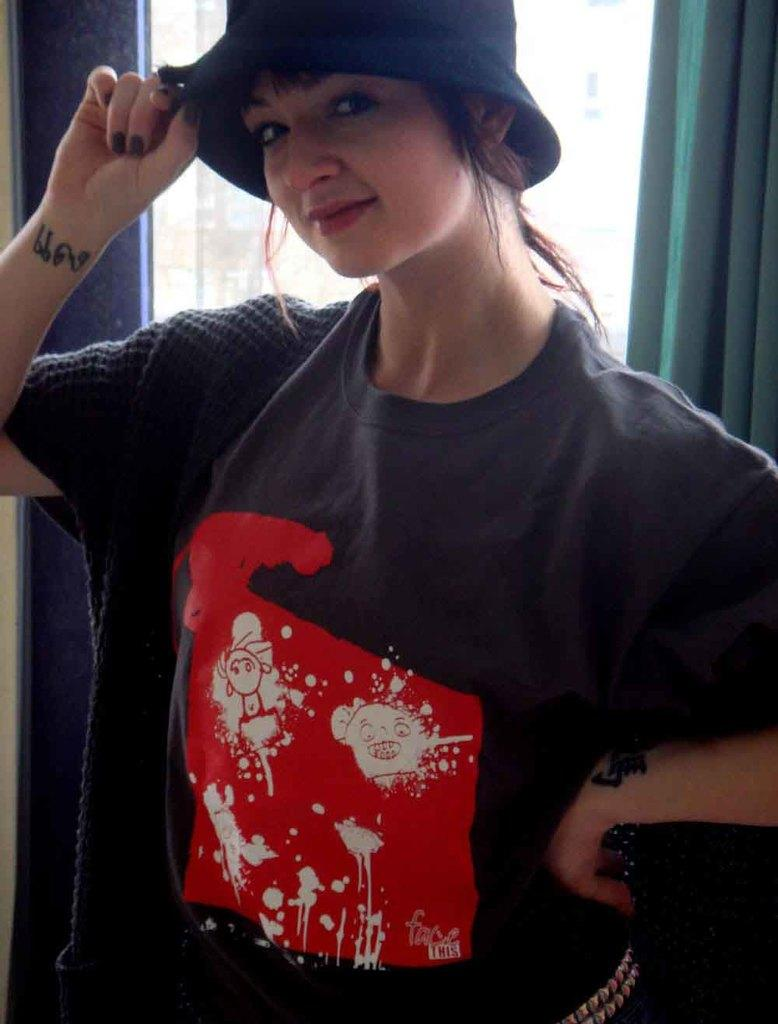What is the main subject of the image? The main subject of the image is a woman. What type of headwear is the woman wearing? The woman is wearing a cap. Can you describe any other elements in the image? Yes, there is a curtain visible in the image. What type of pail can be seen in the image? There is no pail present in the image. What type of trains can be seen in the image? There are no trains present in the image. What type of form is the woman holding in the image? There is no form visible in the image. 